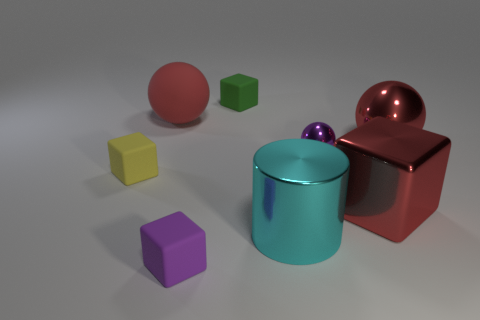What number of large red matte spheres are in front of the small thing that is on the left side of the large red rubber ball? There are no large red matte spheres located in front of the small object that sits to the left of the large red rubber ball. The image illustrates a collection of variously colored shapes, including spheres, cubes, and cylinders, but no large red matte spheres are positioned as described in the question. 